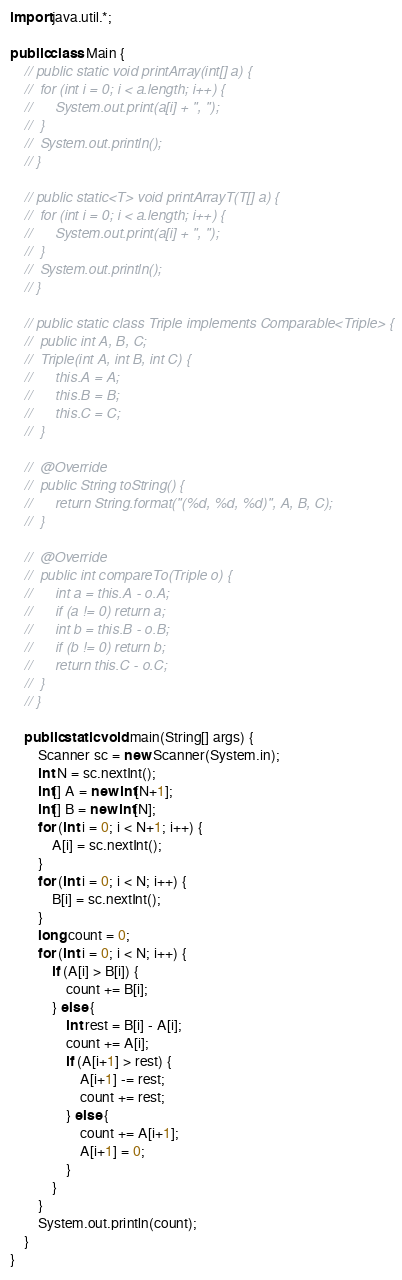Convert code to text. <code><loc_0><loc_0><loc_500><loc_500><_Java_>import java.util.*;

public class Main {
	// public static void printArray(int[] a) {
	// 	for (int i = 0; i < a.length; i++) {
	// 		System.out.print(a[i] + ", ");
	// 	}
	// 	System.out.println();
	// }

	// public static<T> void printArrayT(T[] a) {
	// 	for (int i = 0; i < a.length; i++) {
	// 		System.out.print(a[i] + ", ");
	// 	}
	// 	System.out.println();
	// }

	// public static class Triple implements Comparable<Triple> {
	// 	public int A, B, C;
	// 	Triple(int A, int B, int C) {
	// 		this.A = A;
	// 		this.B = B;
	// 		this.C = C;
	// 	}

	// 	@Override
	// 	public String toString() {
	// 		return String.format("(%d, %d, %d)", A, B, C);
	// 	}

	// 	@Override
	// 	public int compareTo(Triple o) {
	// 		int a = this.A - o.A;
	// 		if (a != 0) return a;
	// 		int b = this.B - o.B;
	// 		if (b != 0) return b;
	// 		return this.C - o.C;
	// 	}
	// }

	public static void main(String[] args) {
		Scanner sc = new Scanner(System.in);
		int N = sc.nextInt();
		int[] A = new int[N+1];
		int[] B = new int[N];
		for (int i = 0; i < N+1; i++) {
			A[i] = sc.nextInt();
		}
		for (int i = 0; i < N; i++) {
			B[i] = sc.nextInt();
		}
		long count = 0;
		for (int i = 0; i < N; i++) {
			if (A[i] > B[i]) {
				count += B[i];
			} else {
				int rest = B[i] - A[i];
				count += A[i];
				if (A[i+1] > rest) {
					A[i+1] -= rest;
					count += rest;
				} else {
					count += A[i+1];
					A[i+1] = 0;
				}
			}
		}
		System.out.println(count);
	}
}
</code> 